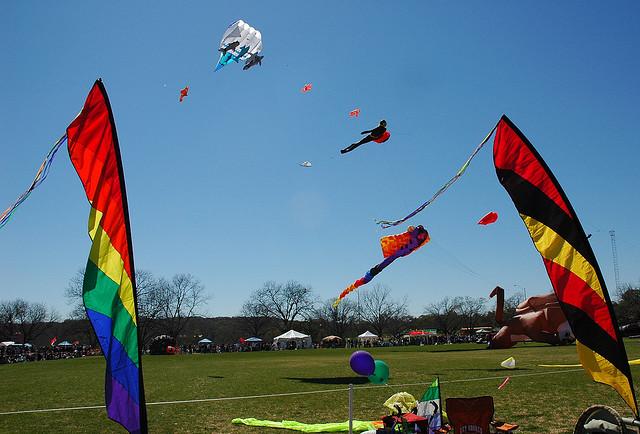How many kites are in this image?
Concise answer only. 5. Is this indoors or outdoors?
Quick response, please. Outdoors. Are there balloons in the sky?
Quick response, please. No. 